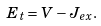<formula> <loc_0><loc_0><loc_500><loc_500>E _ { t } = V - J _ { e x } .</formula> 